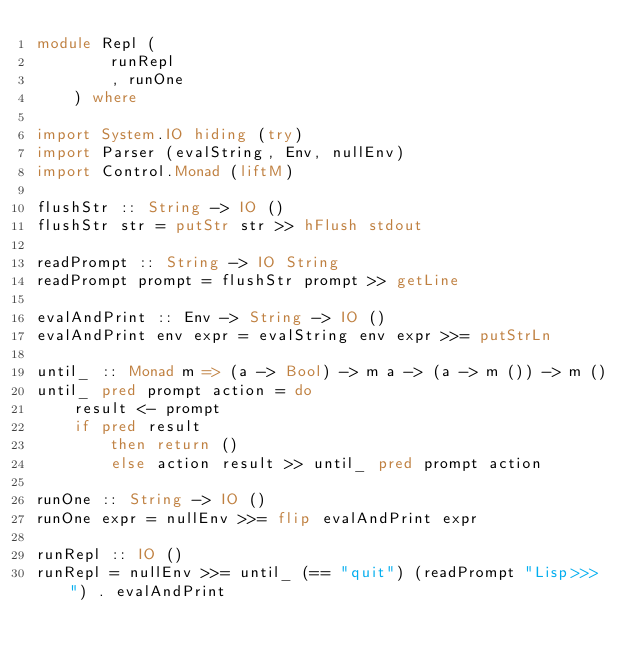Convert code to text. <code><loc_0><loc_0><loc_500><loc_500><_Haskell_>module Repl (
        runRepl
        , runOne
    ) where

import System.IO hiding (try)
import Parser (evalString, Env, nullEnv)
import Control.Monad (liftM)

flushStr :: String -> IO ()
flushStr str = putStr str >> hFlush stdout

readPrompt :: String -> IO String
readPrompt prompt = flushStr prompt >> getLine

evalAndPrint :: Env -> String -> IO ()
evalAndPrint env expr = evalString env expr >>= putStrLn

until_ :: Monad m => (a -> Bool) -> m a -> (a -> m ()) -> m ()
until_ pred prompt action = do
    result <- prompt
    if pred result
        then return ()
        else action result >> until_ pred prompt action

runOne :: String -> IO ()
runOne expr = nullEnv >>= flip evalAndPrint expr

runRepl :: IO ()
runRepl = nullEnv >>= until_ (== "quit") (readPrompt "Lisp>>> ") . evalAndPrint
</code> 